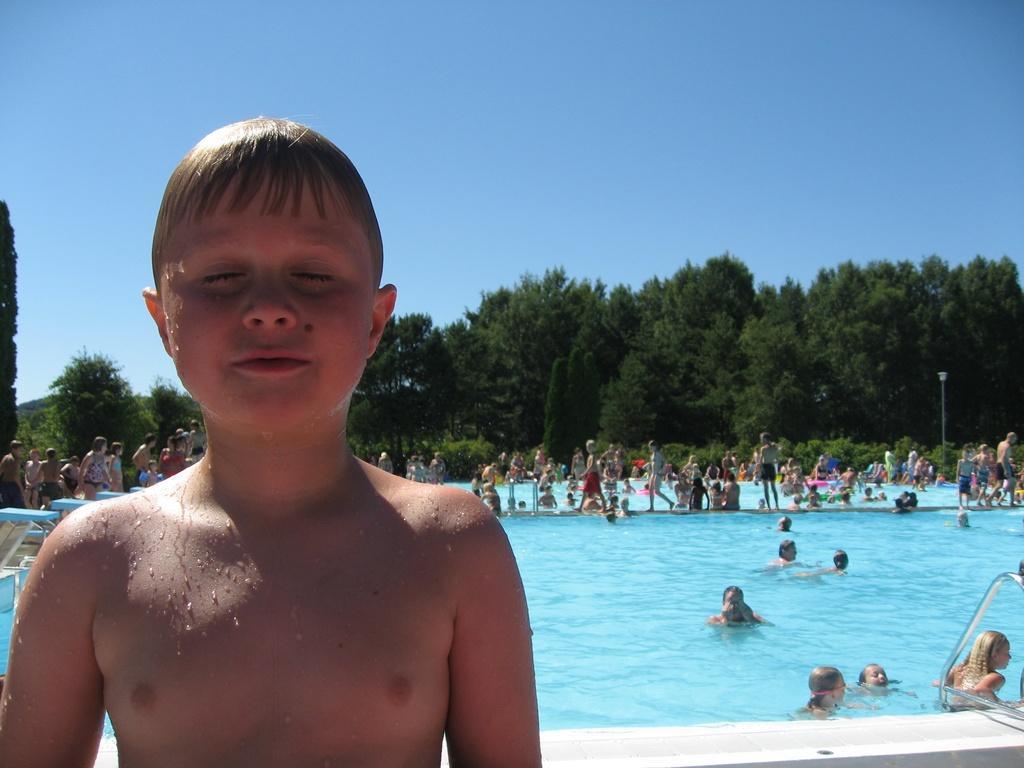How would you summarize this image in a sentence or two? In this image, there are a few people. We can see the swimming pool and a pole. We can also see a metal object on the right. There are a few plants and trees. We can also see the sky and some blue colored objects. 